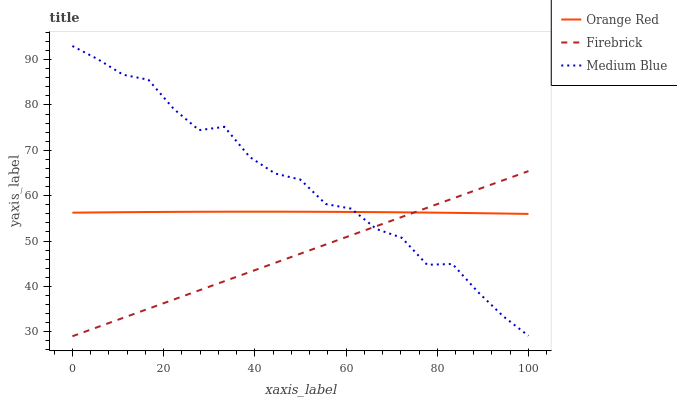Does Firebrick have the minimum area under the curve?
Answer yes or no. Yes. Does Medium Blue have the maximum area under the curve?
Answer yes or no. Yes. Does Orange Red have the minimum area under the curve?
Answer yes or no. No. Does Orange Red have the maximum area under the curve?
Answer yes or no. No. Is Firebrick the smoothest?
Answer yes or no. Yes. Is Medium Blue the roughest?
Answer yes or no. Yes. Is Orange Red the smoothest?
Answer yes or no. No. Is Orange Red the roughest?
Answer yes or no. No. Does Firebrick have the lowest value?
Answer yes or no. Yes. Does Medium Blue have the lowest value?
Answer yes or no. No. Does Medium Blue have the highest value?
Answer yes or no. Yes. Does Orange Red have the highest value?
Answer yes or no. No. Does Medium Blue intersect Firebrick?
Answer yes or no. Yes. Is Medium Blue less than Firebrick?
Answer yes or no. No. Is Medium Blue greater than Firebrick?
Answer yes or no. No. 